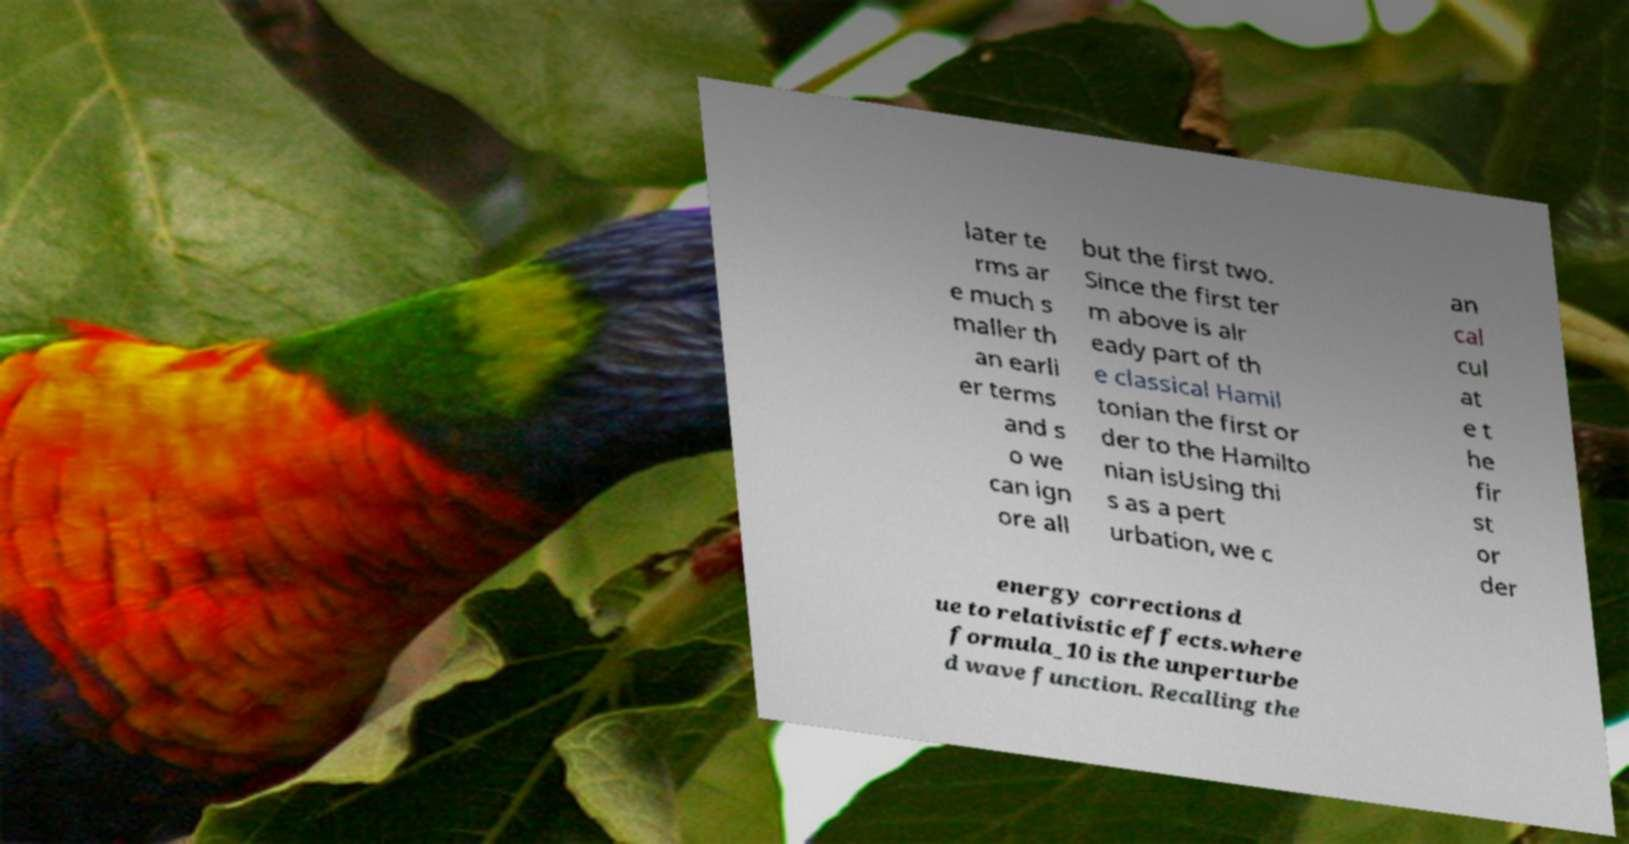There's text embedded in this image that I need extracted. Can you transcribe it verbatim? later te rms ar e much s maller th an earli er terms and s o we can ign ore all but the first two. Since the first ter m above is alr eady part of th e classical Hamil tonian the first or der to the Hamilto nian isUsing thi s as a pert urbation, we c an cal cul at e t he fir st or der energy corrections d ue to relativistic effects.where formula_10 is the unperturbe d wave function. Recalling the 